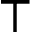<formula> <loc_0><loc_0><loc_500><loc_500>\top</formula> 